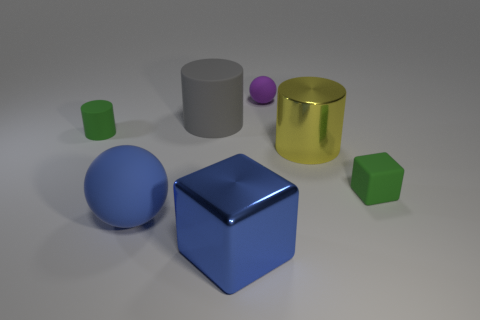Do the metal cylinder and the blue cube have the same size?
Ensure brevity in your answer.  Yes. Does the matte sphere that is behind the rubber cube have the same size as the big yellow cylinder?
Your answer should be compact. No. The sphere on the left side of the big block is what color?
Ensure brevity in your answer.  Blue. How many tiny green matte objects are there?
Offer a terse response. 2. The large blue thing that is made of the same material as the gray object is what shape?
Provide a succinct answer. Sphere. Is the color of the large sphere in front of the tiny purple sphere the same as the object that is on the right side of the large metal cylinder?
Provide a short and direct response. No. Are there an equal number of large shiny cylinders on the right side of the small green rubber cube and large blue metal things?
Provide a short and direct response. No. There is a tiny green rubber block; how many blocks are in front of it?
Offer a terse response. 1. The purple rubber thing is what size?
Give a very brief answer. Small. There is a block that is made of the same material as the large yellow object; what is its color?
Offer a very short reply. Blue. 